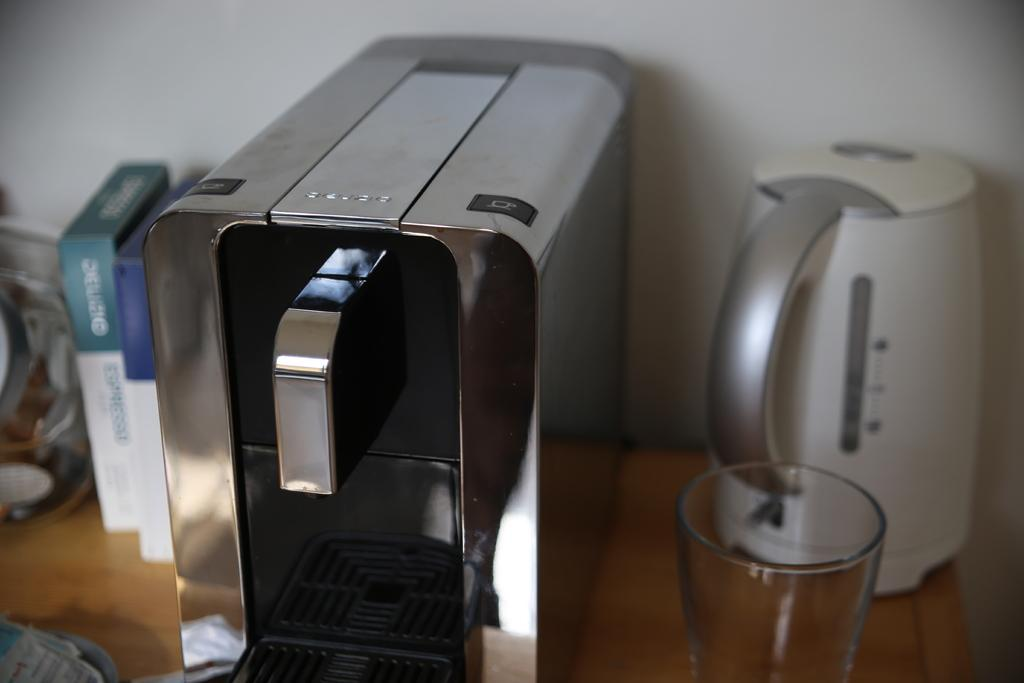What type of machine is visible in the image? There is a machine in the image, but the specific type is not mentioned. What is the machine likely used for? Without more information, it is difficult to determine the exact purpose of the machine. What other objects can be seen on the table in the image? There are other objects on the table in the image, including a kettle and a glass. What is the background of the image? There is a wall in the background of the image. What type of underwear is hanging on the wall in the image? There is no underwear present in the image; it only features a machine, a kettle, a glass, and other objects on the table, as well as a wall in the background. 